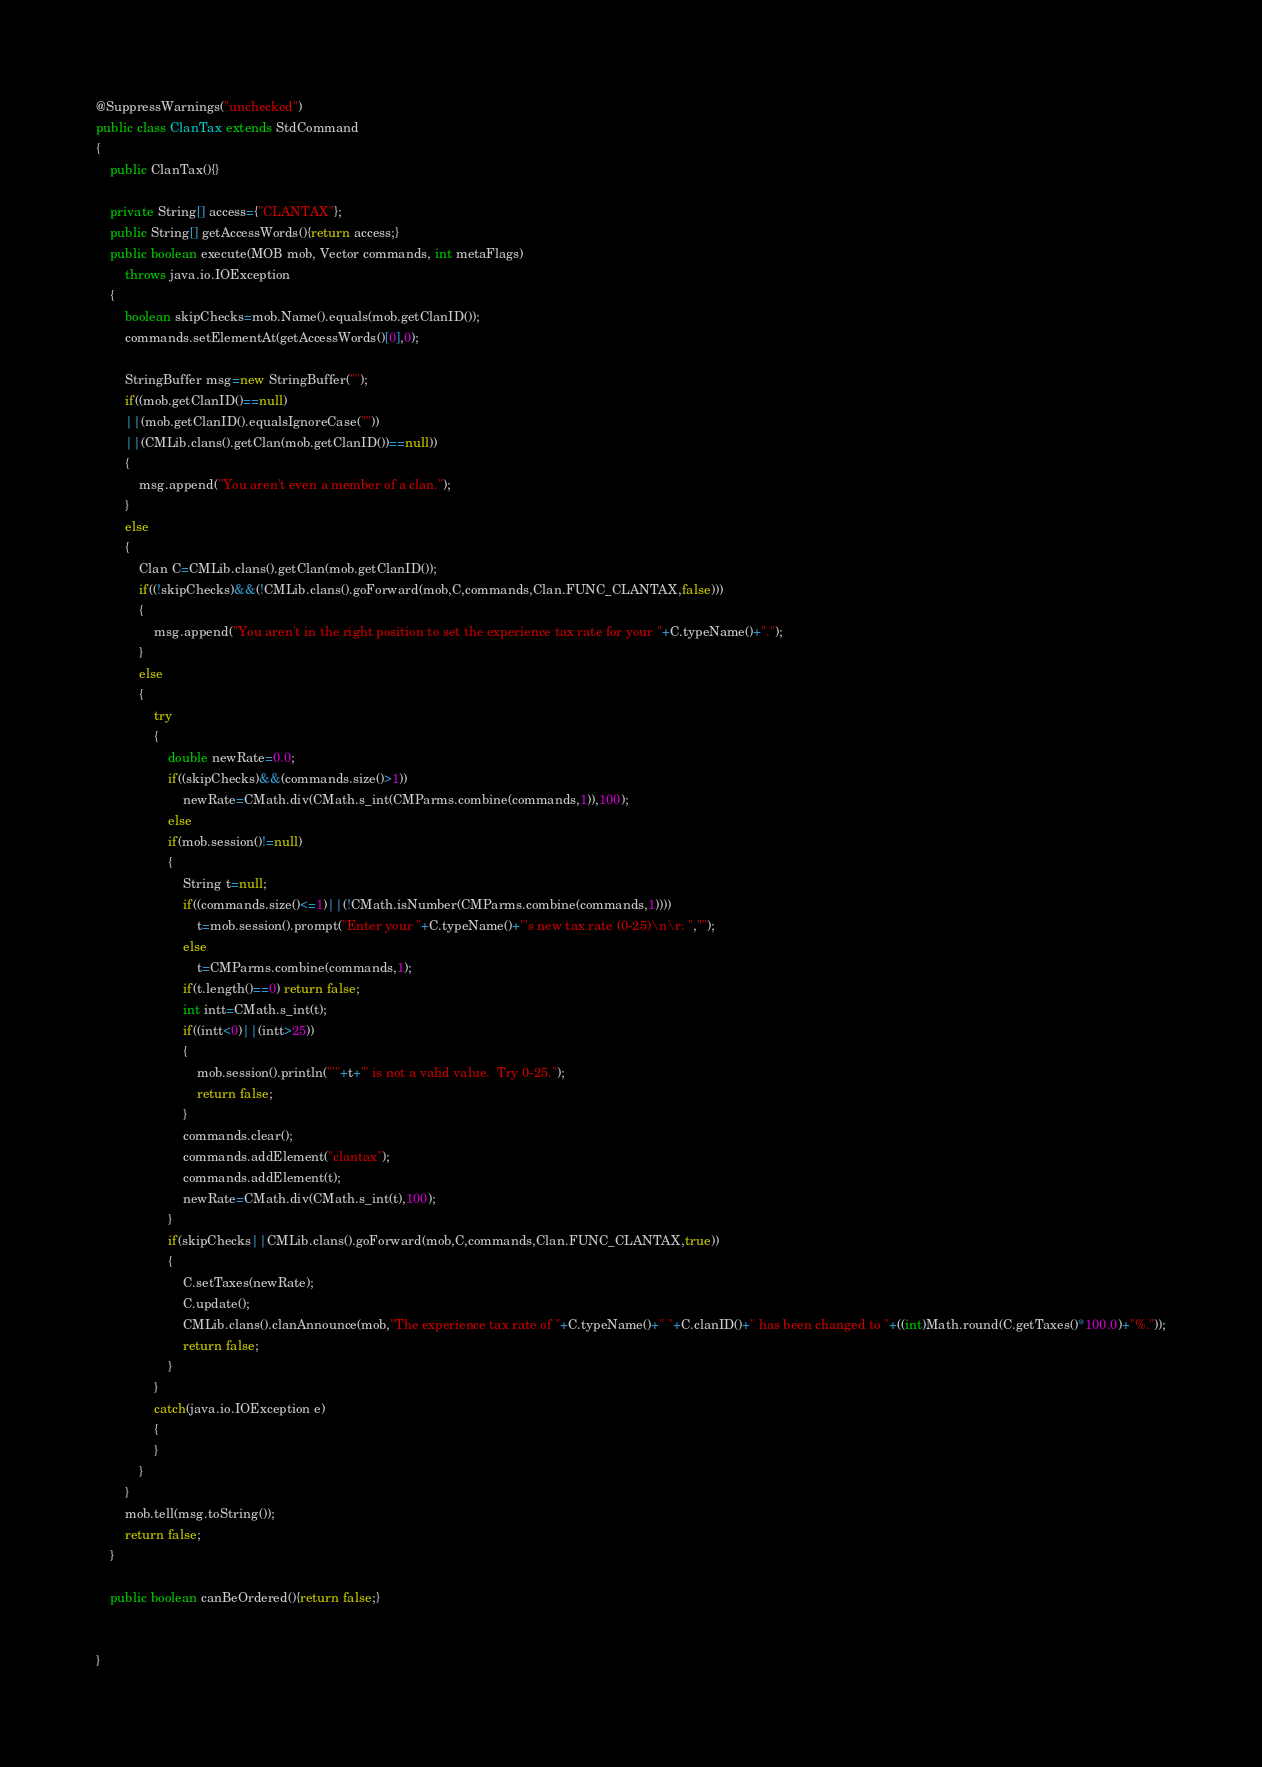<code> <loc_0><loc_0><loc_500><loc_500><_Java_>@SuppressWarnings("unchecked")
public class ClanTax extends StdCommand
{
	public ClanTax(){}

	private String[] access={"CLANTAX"};
	public String[] getAccessWords(){return access;}
	public boolean execute(MOB mob, Vector commands, int metaFlags)
		throws java.io.IOException
	{
		boolean skipChecks=mob.Name().equals(mob.getClanID());
		commands.setElementAt(getAccessWords()[0],0);

		StringBuffer msg=new StringBuffer("");
		if((mob.getClanID()==null)
		||(mob.getClanID().equalsIgnoreCase(""))
		||(CMLib.clans().getClan(mob.getClanID())==null))
		{
			msg.append("You aren't even a member of a clan.");
		}
		else
		{
			Clan C=CMLib.clans().getClan(mob.getClanID());
			if((!skipChecks)&&(!CMLib.clans().goForward(mob,C,commands,Clan.FUNC_CLANTAX,false)))
			{
				msg.append("You aren't in the right position to set the experience tax rate for your "+C.typeName()+".");
			}
			else
			{
				try
				{
					double newRate=0.0;
					if((skipChecks)&&(commands.size()>1))
						newRate=CMath.div(CMath.s_int(CMParms.combine(commands,1)),100);
					else
					if(mob.session()!=null)
					{
						String t=null;
						if((commands.size()<=1)||(!CMath.isNumber(CMParms.combine(commands,1))))
							t=mob.session().prompt("Enter your "+C.typeName()+"'s new tax rate (0-25)\n\r: ","");
						else
							t=CMParms.combine(commands,1);
						if(t.length()==0) return false;
						int intt=CMath.s_int(t);
						if((intt<0)||(intt>25)) 
						{
							mob.session().println("'"+t+"' is not a valid value.  Try 0-25.");
							return false;
						}
						commands.clear();
						commands.addElement("clantax");
						commands.addElement(t);
						newRate=CMath.div(CMath.s_int(t),100);
					}
					if(skipChecks||CMLib.clans().goForward(mob,C,commands,Clan.FUNC_CLANTAX,true))
					{
						C.setTaxes(newRate);
						C.update();
						CMLib.clans().clanAnnounce(mob,"The experience tax rate of "+C.typeName()+" "+C.clanID()+" has been changed to "+((int)Math.round(C.getTaxes()*100.0)+"%."));
						return false;
					}
				}
				catch(java.io.IOException e)
				{
				}
			}
		}
		mob.tell(msg.toString());
		return false;
	}
	
	public boolean canBeOrdered(){return false;}

	
}
</code> 